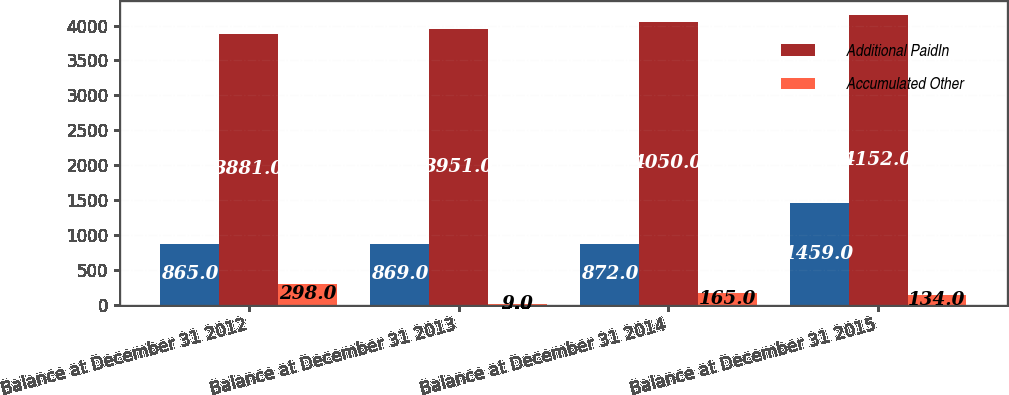<chart> <loc_0><loc_0><loc_500><loc_500><stacked_bar_chart><ecel><fcel>Balance at December 31 2012<fcel>Balance at December 31 2013<fcel>Balance at December 31 2014<fcel>Balance at December 31 2015<nl><fcel>nan<fcel>865<fcel>869<fcel>872<fcel>1459<nl><fcel>Additional PaidIn<fcel>3881<fcel>3951<fcel>4050<fcel>4152<nl><fcel>Accumulated Other<fcel>298<fcel>9<fcel>165<fcel>134<nl></chart> 